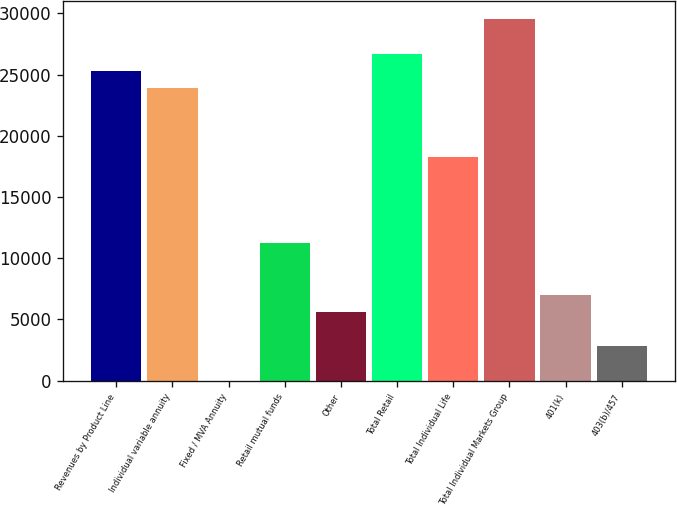<chart> <loc_0><loc_0><loc_500><loc_500><bar_chart><fcel>Revenues by Product Line<fcel>Individual variable annuity<fcel>Fixed / MVA Annuity<fcel>Retail mutual funds<fcel>Other<fcel>Total Retail<fcel>Total Individual Life<fcel>Total Individual Markets Group<fcel>401(k)<fcel>403(b)/457<nl><fcel>25314.4<fcel>23908.1<fcel>1<fcel>11251.4<fcel>5626.2<fcel>26720.7<fcel>18282.9<fcel>29533.3<fcel>7032.5<fcel>2813.6<nl></chart> 